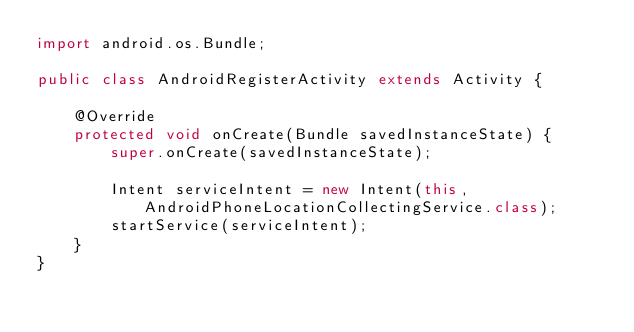<code> <loc_0><loc_0><loc_500><loc_500><_Java_>import android.os.Bundle;

public class AndroidRegisterActivity extends Activity {

    @Override
    protected void onCreate(Bundle savedInstanceState) {
        super.onCreate(savedInstanceState);

        Intent serviceIntent = new Intent(this, AndroidPhoneLocationCollectingService.class);
        startService(serviceIntent);
    }
}
</code> 